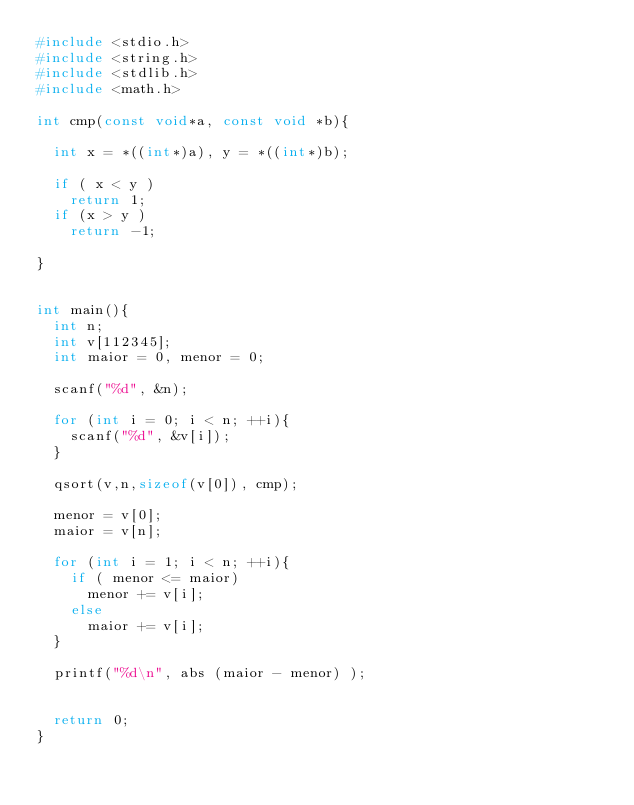<code> <loc_0><loc_0><loc_500><loc_500><_C_>#include <stdio.h>
#include <string.h>
#include <stdlib.h>
#include <math.h>

int cmp(const void*a, const void *b){

	int x = *((int*)a), y = *((int*)b);

	if ( x < y )
		return 1;
	if (x > y )
		return -1;

}


int main(){
	int n;
	int v[112345];
	int maior = 0, menor = 0;

	scanf("%d", &n);

	for (int i = 0; i < n; ++i){
		scanf("%d", &v[i]);
	}

	qsort(v,n,sizeof(v[0]), cmp);

	menor = v[0];
	maior = v[n];

	for (int i = 1; i < n; ++i){
		if ( menor <= maior)
			menor += v[i];
		else
			maior += v[i];
	}

	printf("%d\n", abs (maior - menor) );


	return 0;
}</code> 